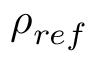Convert formula to latex. <formula><loc_0><loc_0><loc_500><loc_500>\rho _ { r e f }</formula> 